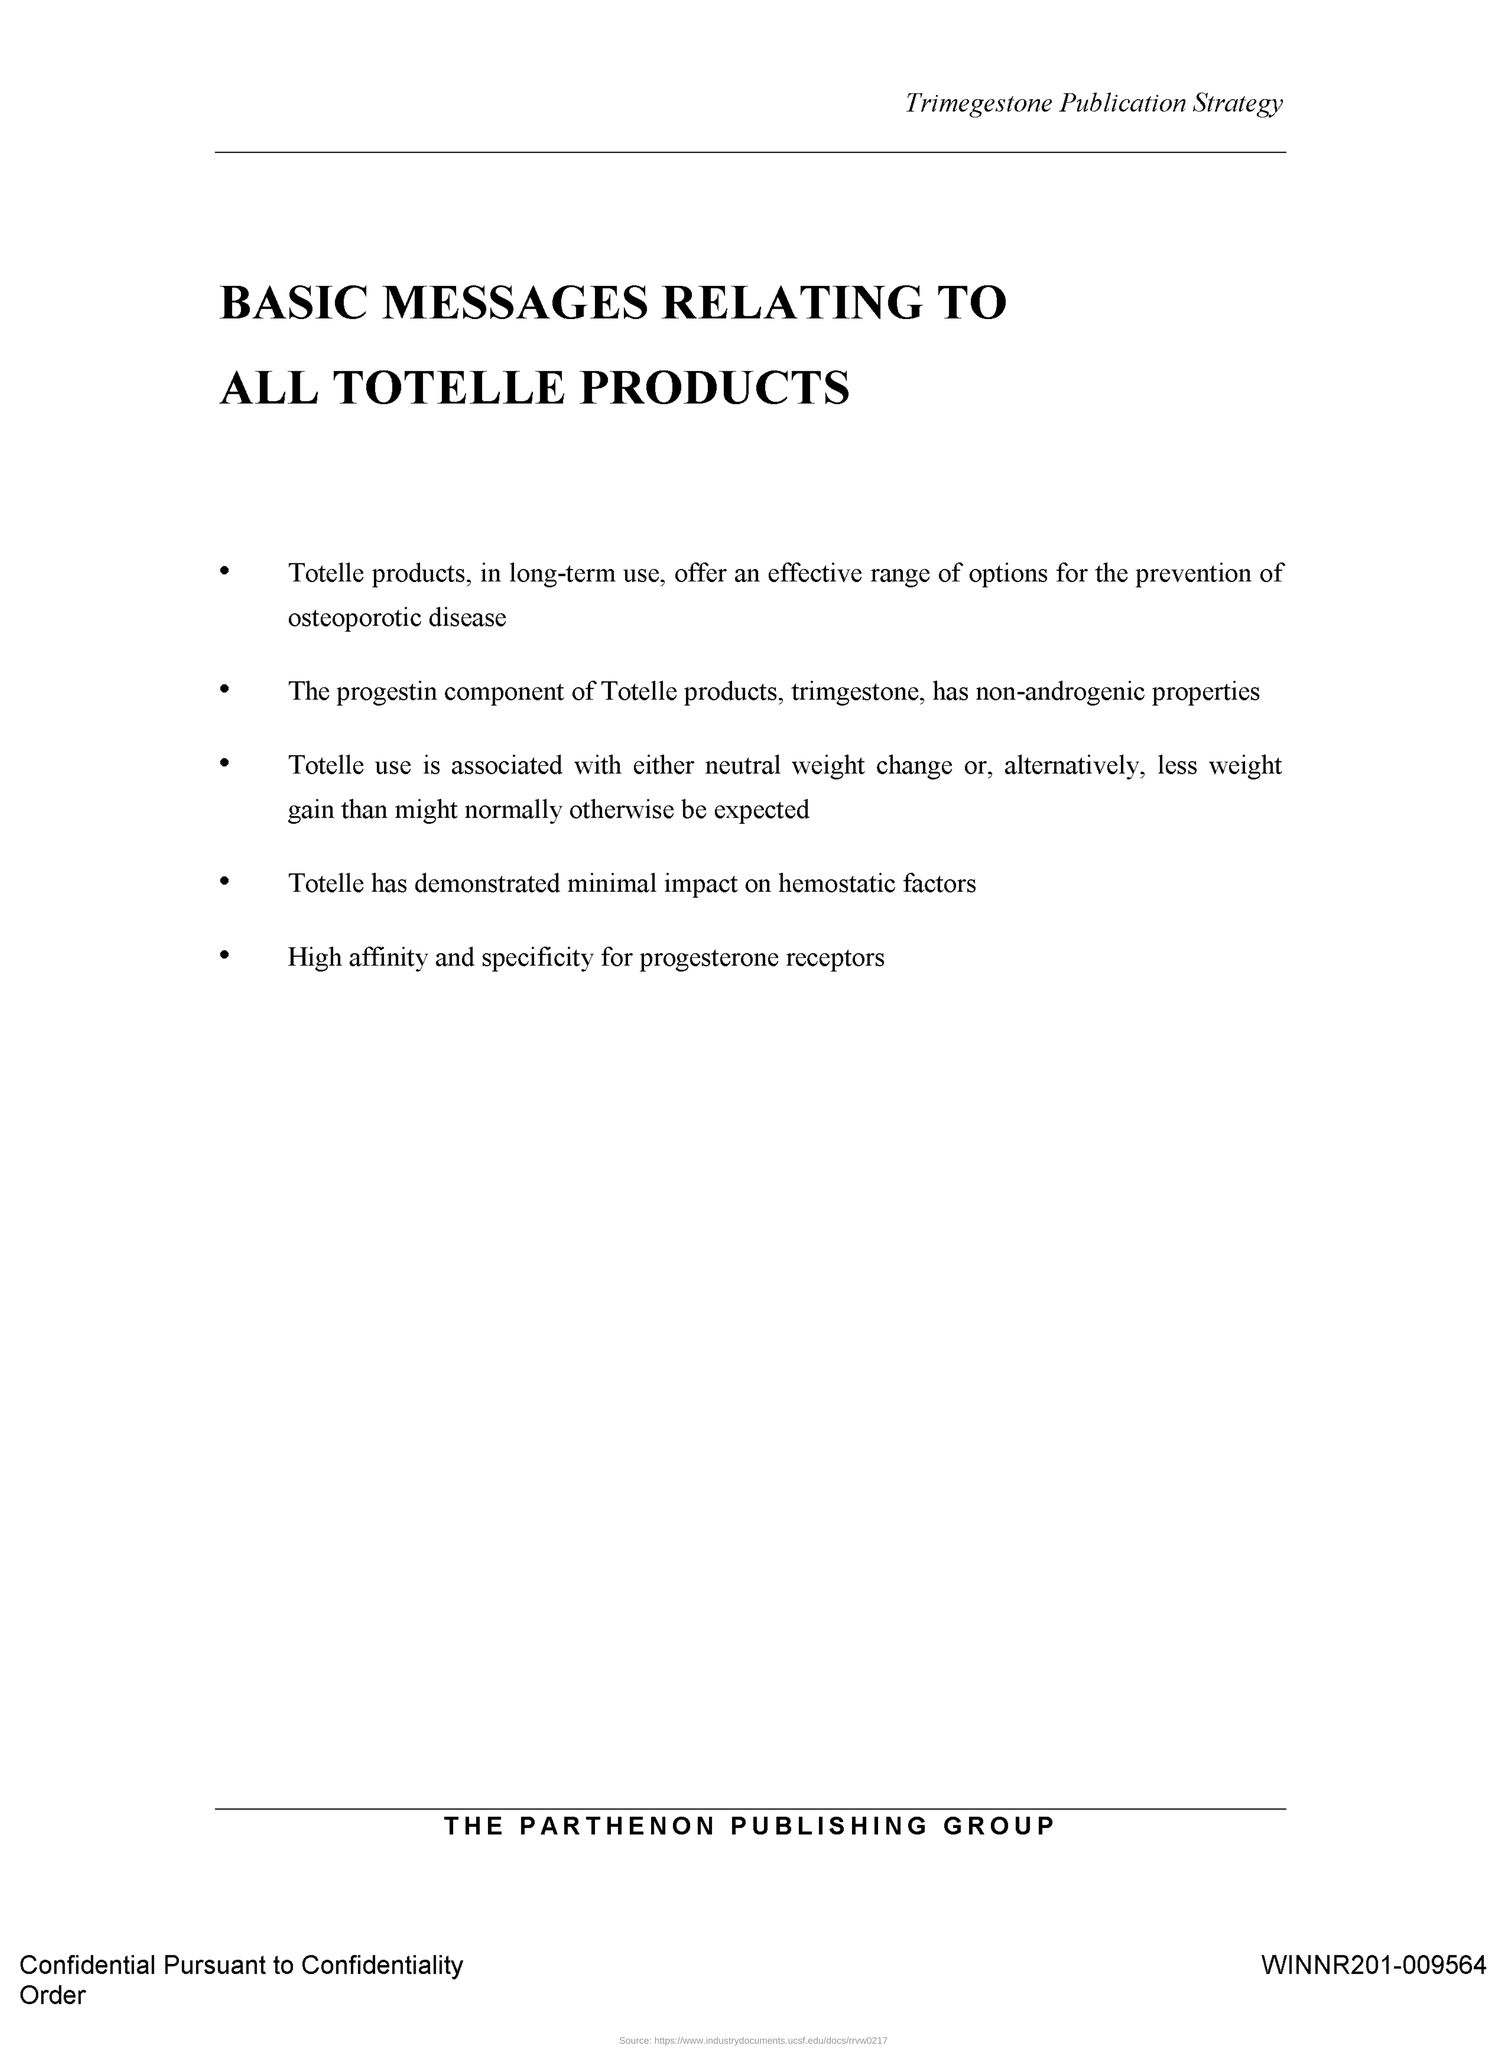What is the Document Number?
Ensure brevity in your answer.  WINNR201-009564. 